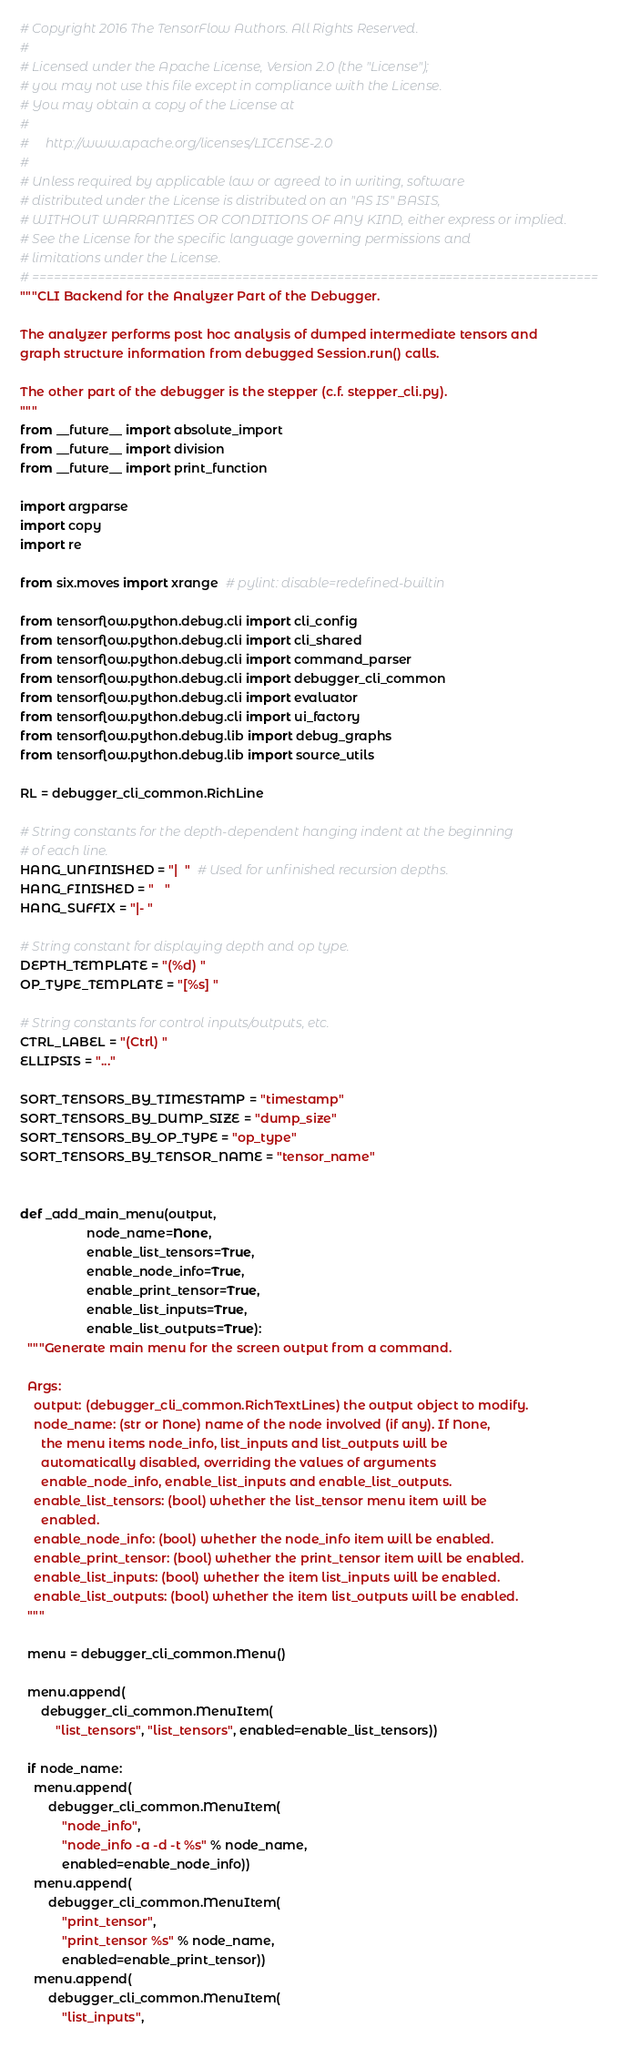Convert code to text. <code><loc_0><loc_0><loc_500><loc_500><_Python_># Copyright 2016 The TensorFlow Authors. All Rights Reserved.
#
# Licensed under the Apache License, Version 2.0 (the "License");
# you may not use this file except in compliance with the License.
# You may obtain a copy of the License at
#
#     http://www.apache.org/licenses/LICENSE-2.0
#
# Unless required by applicable law or agreed to in writing, software
# distributed under the License is distributed on an "AS IS" BASIS,
# WITHOUT WARRANTIES OR CONDITIONS OF ANY KIND, either express or implied.
# See the License for the specific language governing permissions and
# limitations under the License.
# ==============================================================================
"""CLI Backend for the Analyzer Part of the Debugger.

The analyzer performs post hoc analysis of dumped intermediate tensors and
graph structure information from debugged Session.run() calls.

The other part of the debugger is the stepper (c.f. stepper_cli.py).
"""
from __future__ import absolute_import
from __future__ import division
from __future__ import print_function

import argparse
import copy
import re

from six.moves import xrange  # pylint: disable=redefined-builtin

from tensorflow.python.debug.cli import cli_config
from tensorflow.python.debug.cli import cli_shared
from tensorflow.python.debug.cli import command_parser
from tensorflow.python.debug.cli import debugger_cli_common
from tensorflow.python.debug.cli import evaluator
from tensorflow.python.debug.cli import ui_factory
from tensorflow.python.debug.lib import debug_graphs
from tensorflow.python.debug.lib import source_utils

RL = debugger_cli_common.RichLine

# String constants for the depth-dependent hanging indent at the beginning
# of each line.
HANG_UNFINISHED = "|  "  # Used for unfinished recursion depths.
HANG_FINISHED = "   "
HANG_SUFFIX = "|- "

# String constant for displaying depth and op type.
DEPTH_TEMPLATE = "(%d) "
OP_TYPE_TEMPLATE = "[%s] "

# String constants for control inputs/outputs, etc.
CTRL_LABEL = "(Ctrl) "
ELLIPSIS = "..."

SORT_TENSORS_BY_TIMESTAMP = "timestamp"
SORT_TENSORS_BY_DUMP_SIZE = "dump_size"
SORT_TENSORS_BY_OP_TYPE = "op_type"
SORT_TENSORS_BY_TENSOR_NAME = "tensor_name"


def _add_main_menu(output,
                   node_name=None,
                   enable_list_tensors=True,
                   enable_node_info=True,
                   enable_print_tensor=True,
                   enable_list_inputs=True,
                   enable_list_outputs=True):
  """Generate main menu for the screen output from a command.

  Args:
    output: (debugger_cli_common.RichTextLines) the output object to modify.
    node_name: (str or None) name of the node involved (if any). If None,
      the menu items node_info, list_inputs and list_outputs will be
      automatically disabled, overriding the values of arguments
      enable_node_info, enable_list_inputs and enable_list_outputs.
    enable_list_tensors: (bool) whether the list_tensor menu item will be
      enabled.
    enable_node_info: (bool) whether the node_info item will be enabled.
    enable_print_tensor: (bool) whether the print_tensor item will be enabled.
    enable_list_inputs: (bool) whether the item list_inputs will be enabled.
    enable_list_outputs: (bool) whether the item list_outputs will be enabled.
  """

  menu = debugger_cli_common.Menu()

  menu.append(
      debugger_cli_common.MenuItem(
          "list_tensors", "list_tensors", enabled=enable_list_tensors))

  if node_name:
    menu.append(
        debugger_cli_common.MenuItem(
            "node_info",
            "node_info -a -d -t %s" % node_name,
            enabled=enable_node_info))
    menu.append(
        debugger_cli_common.MenuItem(
            "print_tensor",
            "print_tensor %s" % node_name,
            enabled=enable_print_tensor))
    menu.append(
        debugger_cli_common.MenuItem(
            "list_inputs",</code> 